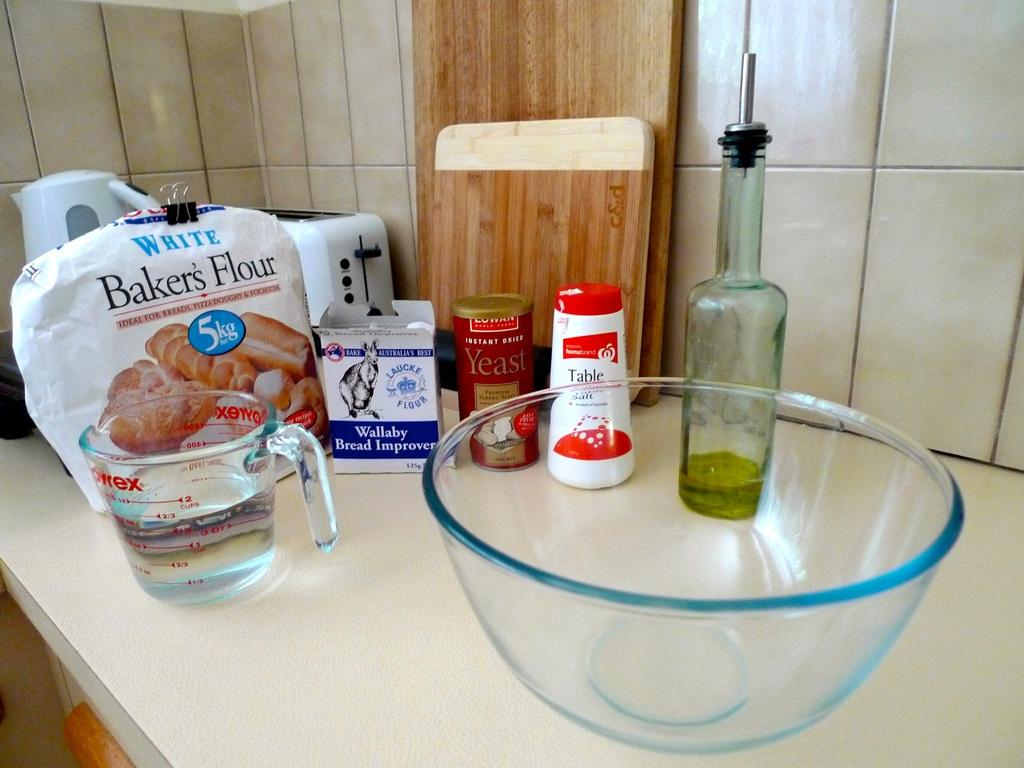What is the primary color of the tiles in the image? The image contains white color tiles. What type of furniture is present in the image? There is a table in the image. What is placed on the table in the image? There is a bowl, a bottle, a yeast bottle, a bread improvement box, and bakers flour on the table. What type of drug can be seen in the image? There is no drug present in the image; it contains a bowl, a bottle, a yeast bottle, a bread improvement box, and bakers flour on a table with white color tiles. 